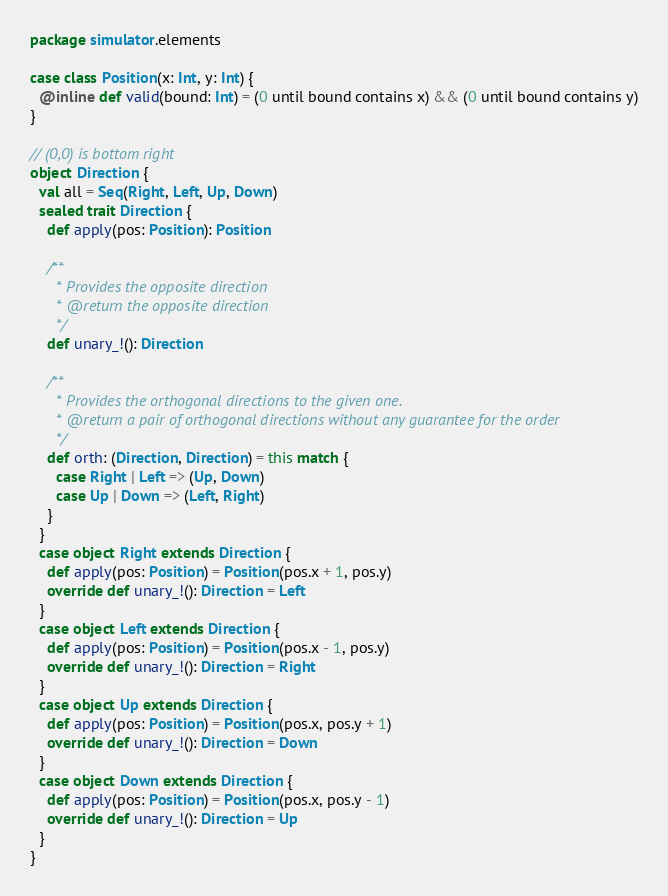Convert code to text. <code><loc_0><loc_0><loc_500><loc_500><_Scala_>package simulator.elements

case class Position(x: Int, y: Int) {
  @inline def valid(bound: Int) = (0 until bound contains x) && (0 until bound contains y)
}

// (0,0) is bottom right
object Direction {
  val all = Seq(Right, Left, Up, Down)
  sealed trait Direction {
    def apply(pos: Position): Position

    /**
      * Provides the opposite direction
      * @return the opposite direction
      */
    def unary_!(): Direction

    /**
      * Provides the orthogonal directions to the given one.
      * @return a pair of orthogonal directions without any guarantee for the order
      */
    def orth: (Direction, Direction) = this match {
      case Right | Left => (Up, Down)
      case Up | Down => (Left, Right)
    }
  }
  case object Right extends Direction {
    def apply(pos: Position) = Position(pos.x + 1, pos.y)
    override def unary_!(): Direction = Left
  }
  case object Left extends Direction {
    def apply(pos: Position) = Position(pos.x - 1, pos.y)
    override def unary_!(): Direction = Right
  }
  case object Up extends Direction {
    def apply(pos: Position) = Position(pos.x, pos.y + 1)
    override def unary_!(): Direction = Down
  }
  case object Down extends Direction {
    def apply(pos: Position) = Position(pos.x, pos.y - 1)
    override def unary_!(): Direction = Up
  }
}
</code> 